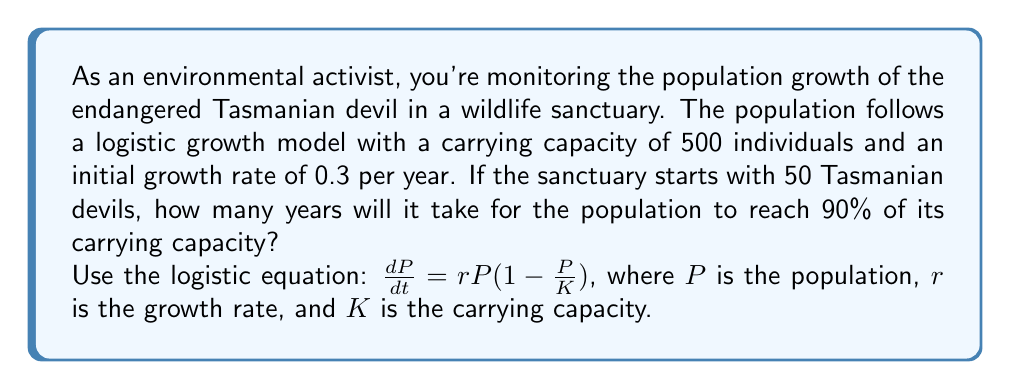Provide a solution to this math problem. To solve this problem, we'll use the integrated form of the logistic equation:

$$P(t) = \frac{K}{1 + (\frac{K}{P_0} - 1)e^{-rt}}$$

Where:
$P(t)$ is the population at time $t$
$K$ is the carrying capacity (500)
$P_0$ is the initial population (50)
$r$ is the growth rate (0.3)
$t$ is the time in years

We want to find $t$ when $P(t) = 0.9K = 450$

1. Substitute the known values into the equation:

   $$450 = \frac{500}{1 + (\frac{500}{50} - 1)e^{-0.3t}}$$

2. Simplify:

   $$450 = \frac{500}{1 + 9e^{-0.3t}}$$

3. Multiply both sides by $(1 + 9e^{-0.3t})$:

   $$450(1 + 9e^{-0.3t}) = 500$$

4. Expand:

   $$450 + 4050e^{-0.3t} = 500$$

5. Subtract 450 from both sides:

   $$4050e^{-0.3t} = 50$$

6. Divide both sides by 4050:

   $$e^{-0.3t} = \frac{50}{4050} = \frac{1}{81}$$

7. Take the natural logarithm of both sides:

   $$-0.3t = \ln(\frac{1}{81})$$

8. Divide both sides by -0.3:

   $$t = -\frac{\ln(\frac{1}{81})}{0.3} = \frac{\ln(81)}{0.3}$$

9. Calculate the final result:

   $$t \approx 14.57 \text{ years}$$
Answer: It will take approximately 14.57 years for the Tasmanian devil population to reach 90% of its carrying capacity in the wildlife sanctuary. 